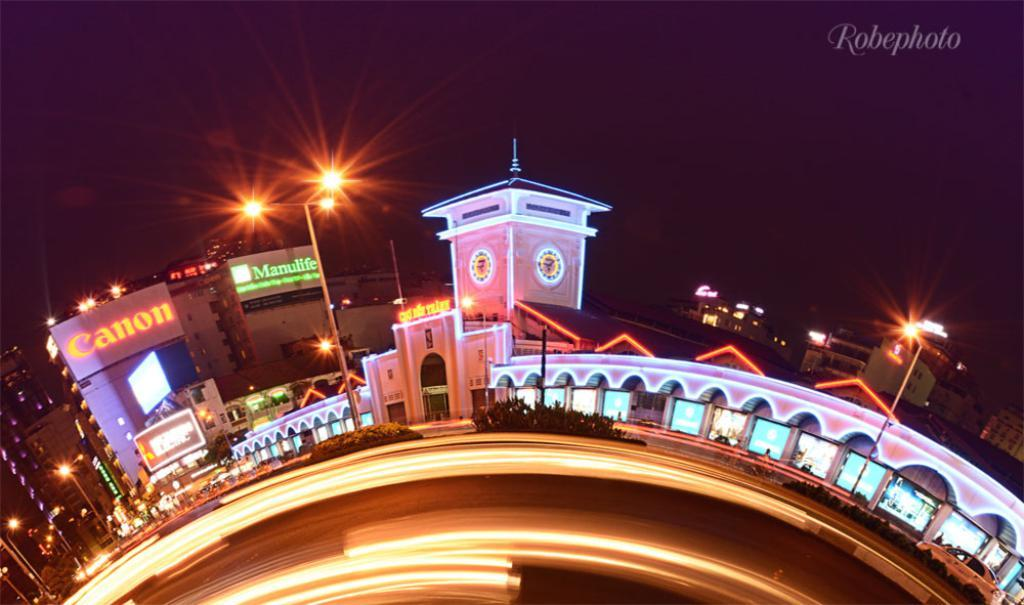<image>
Render a clear and concise summary of the photo. A photo of a bridge with the name Robephoto on the top right. 